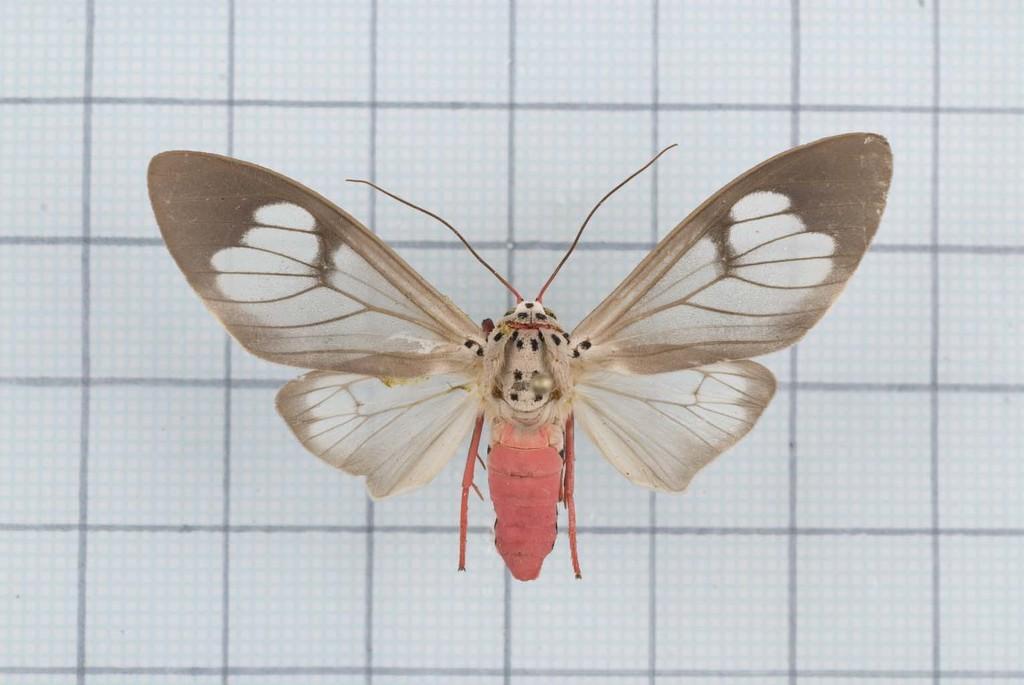Please provide a concise description of this image. In the foreground of this image, there is a fly on a white surface on which there are lines. 